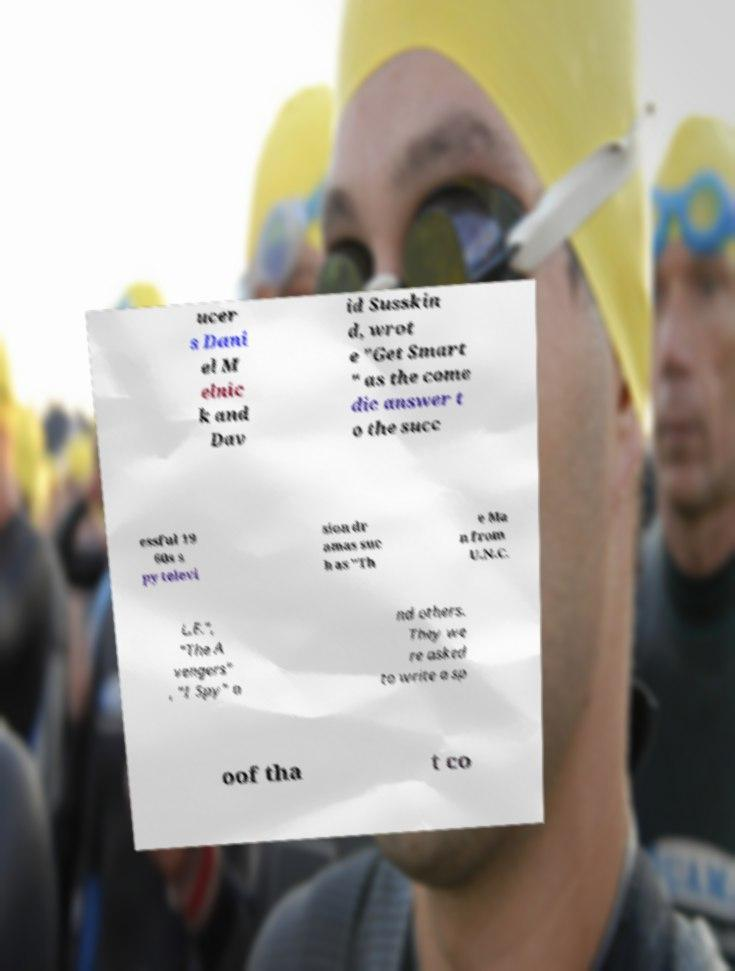Can you read and provide the text displayed in the image?This photo seems to have some interesting text. Can you extract and type it out for me? ucer s Dani el M elnic k and Dav id Susskin d, wrot e "Get Smart " as the come dic answer t o the succ essful 19 60s s py televi sion dr amas suc h as "Th e Ma n from U.N.C. L.E.", "The A vengers" , "I Spy" a nd others. They we re asked to write a sp oof tha t co 